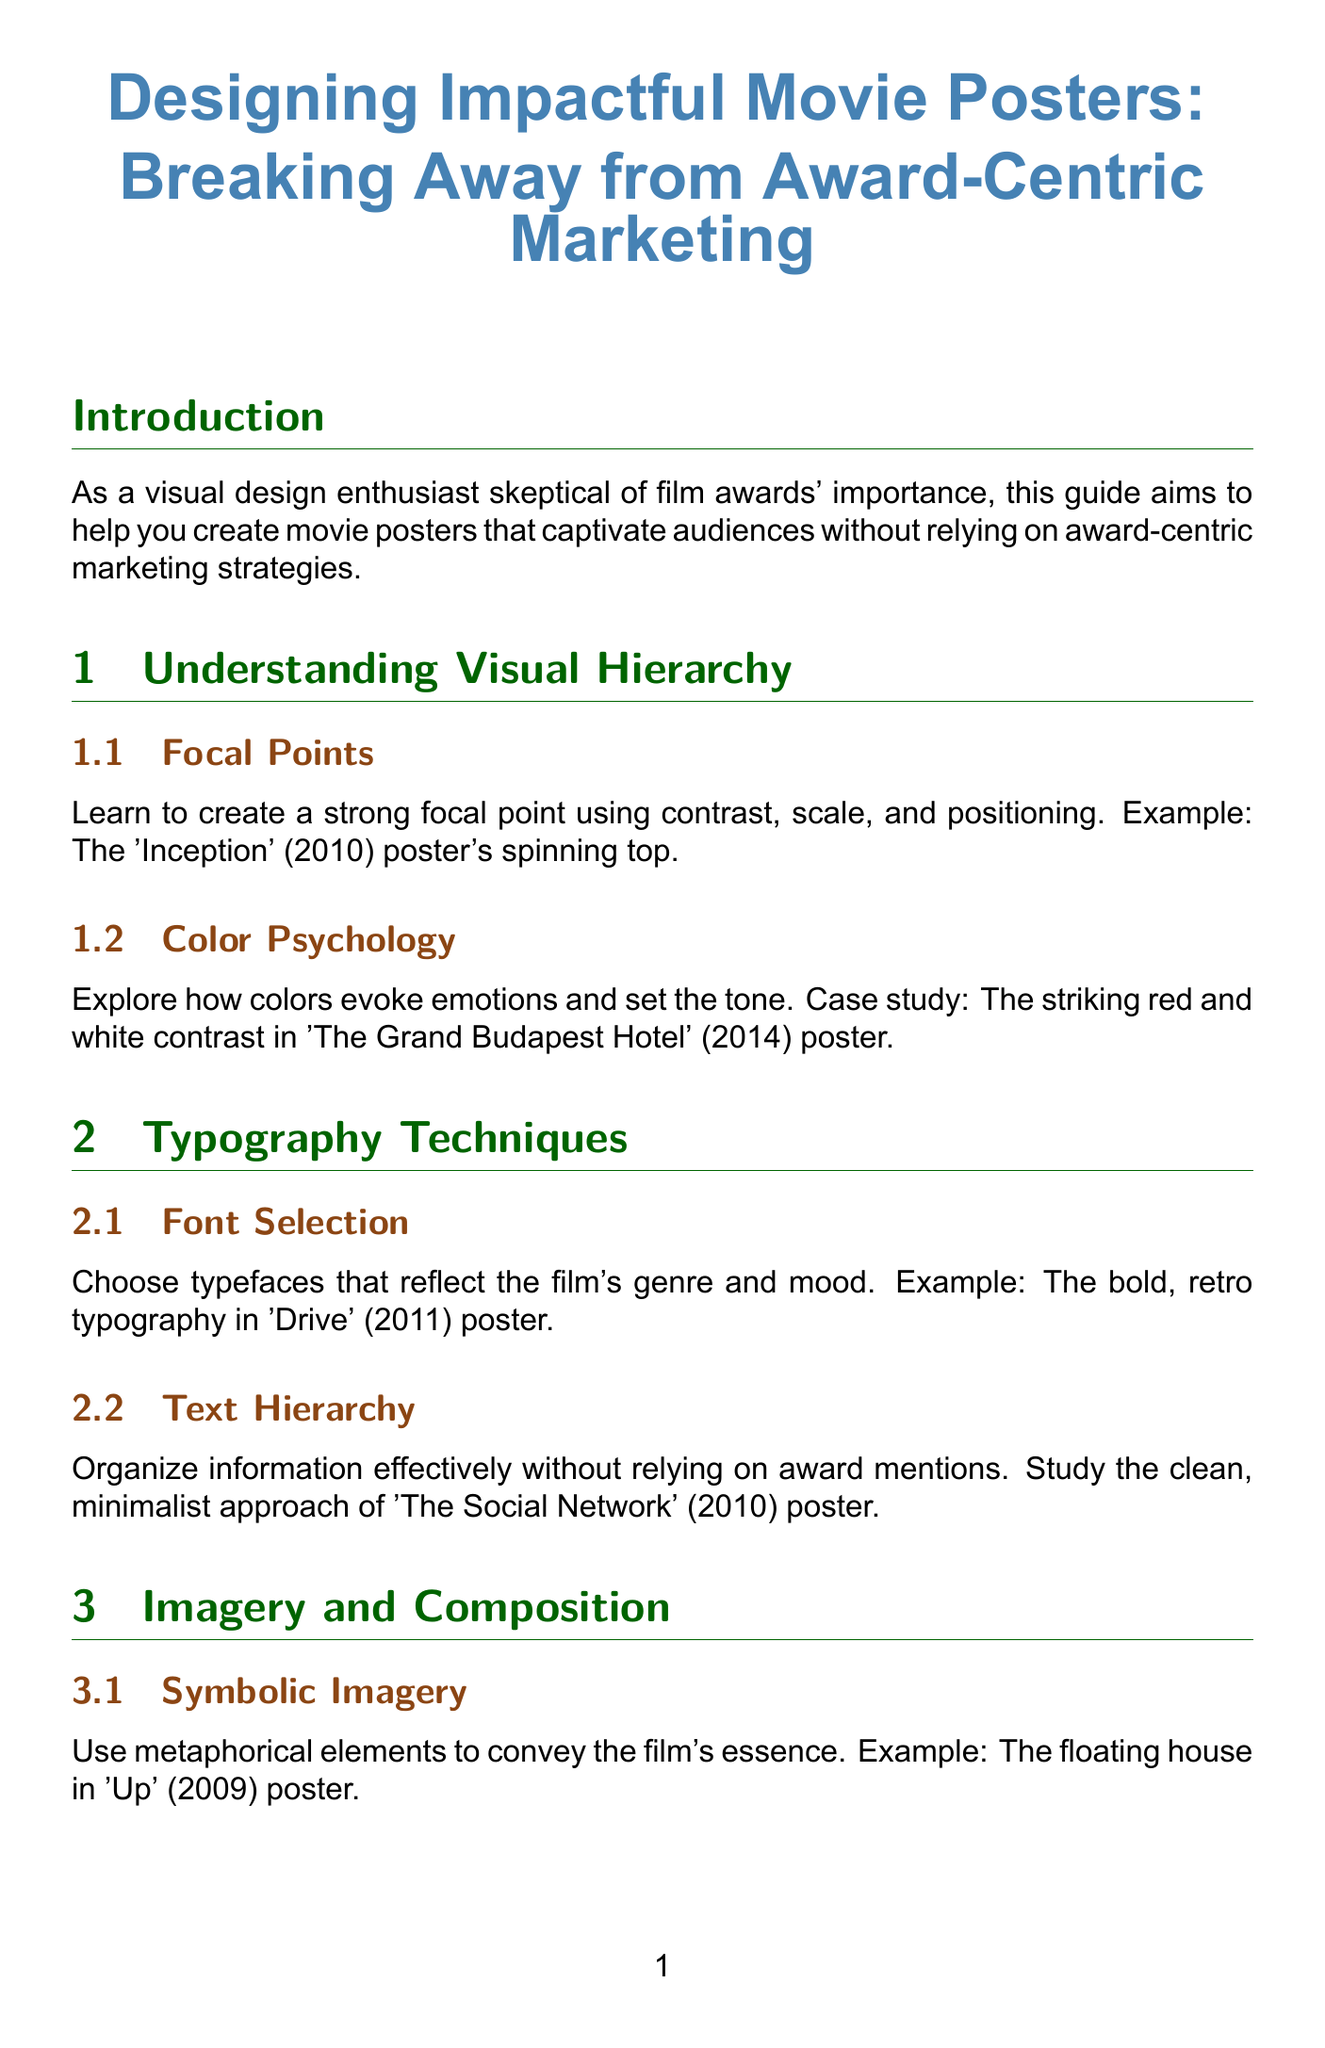What is the title of the guide? The title is explicitly stated at the beginning of the document.
Answer: Designing Impactful Movie Posters: Breaking Away from Award-Centric Marketing What year was the example film 'Inception' released? The year of release is mentioned in the context of the focal point example.
Answer: 2010 Which film's poster showcases striking red and white contrast? The case study for color psychology highlights a specific film's poster.
Answer: The Grand Budapest Hotel What is a technique mentioned for effective information organization? The section discusses methods for organizing text without awards, specifying a particular approach.
Answer: Text Hierarchy Name one director whose vision is highlighted in the guide. The guide provides a specific director as an example of emphasizing unique selling points.
Answer: Wes Anderson What unique element is used in the 'Up' poster? The guide mentions a metaphorical element to convey the film's essence in this poster.
Answer: Floating house Which platform is suggested for optimizing poster sharing? The guide emphasizes the importance of designing for a specific social media platform for visibility.
Answer: Instagram What is one method discussed for creating intrigue in posters? The guide provides examples of how to spark curiosity through design.
Answer: Mysterious imagery What does the conclusion recap? The conclusion summarizes key strategies presented throughout the document.
Answer: Impactful movie posters that don't rely on award recognition 